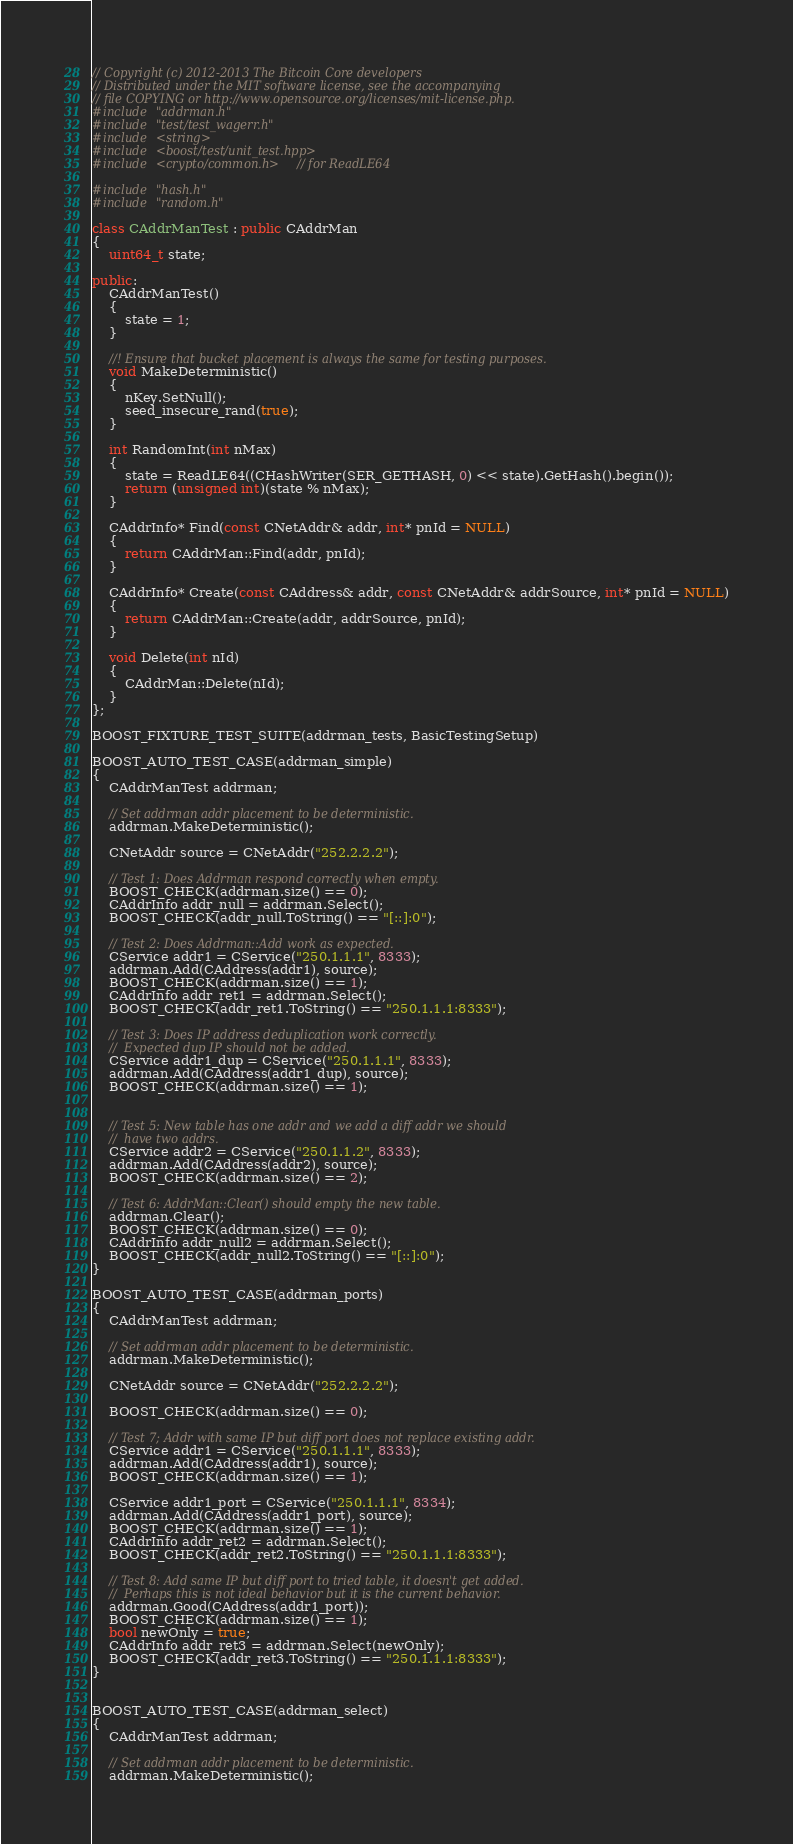<code> <loc_0><loc_0><loc_500><loc_500><_C++_>// Copyright (c) 2012-2013 The Bitcoin Core developers
// Distributed under the MIT software license, see the accompanying
// file COPYING or http://www.opensource.org/licenses/mit-license.php.
#include "addrman.h"
#include "test/test_wagerr.h"
#include <string>
#include <boost/test/unit_test.hpp>
#include <crypto/common.h> // for ReadLE64

#include "hash.h"
#include "random.h"

class CAddrManTest : public CAddrMan
{
    uint64_t state;

public:
    CAddrManTest()
    {
        state = 1;
    }

    //! Ensure that bucket placement is always the same for testing purposes.
    void MakeDeterministic()
    {
        nKey.SetNull();
        seed_insecure_rand(true);
    }

    int RandomInt(int nMax)
    {
        state = ReadLE64((CHashWriter(SER_GETHASH, 0) << state).GetHash().begin());
        return (unsigned int)(state % nMax);
    }

    CAddrInfo* Find(const CNetAddr& addr, int* pnId = NULL)
    {
        return CAddrMan::Find(addr, pnId);
    }

    CAddrInfo* Create(const CAddress& addr, const CNetAddr& addrSource, int* pnId = NULL)
    {
        return CAddrMan::Create(addr, addrSource, pnId);
    }

    void Delete(int nId)
    {
        CAddrMan::Delete(nId);
    }
};

BOOST_FIXTURE_TEST_SUITE(addrman_tests, BasicTestingSetup)

BOOST_AUTO_TEST_CASE(addrman_simple)
{
    CAddrManTest addrman;

    // Set addrman addr placement to be deterministic.
    addrman.MakeDeterministic();

    CNetAddr source = CNetAddr("252.2.2.2");

    // Test 1: Does Addrman respond correctly when empty.
    BOOST_CHECK(addrman.size() == 0);
    CAddrInfo addr_null = addrman.Select();
    BOOST_CHECK(addr_null.ToString() == "[::]:0");

    // Test 2: Does Addrman::Add work as expected.
    CService addr1 = CService("250.1.1.1", 8333);
    addrman.Add(CAddress(addr1), source);
    BOOST_CHECK(addrman.size() == 1);
    CAddrInfo addr_ret1 = addrman.Select();
    BOOST_CHECK(addr_ret1.ToString() == "250.1.1.1:8333");

    // Test 3: Does IP address deduplication work correctly.
    //  Expected dup IP should not be added.
    CService addr1_dup = CService("250.1.1.1", 8333);
    addrman.Add(CAddress(addr1_dup), source);
    BOOST_CHECK(addrman.size() == 1);


    // Test 5: New table has one addr and we add a diff addr we should
    //  have two addrs.
    CService addr2 = CService("250.1.1.2", 8333);
    addrman.Add(CAddress(addr2), source);
    BOOST_CHECK(addrman.size() == 2);

    // Test 6: AddrMan::Clear() should empty the new table.
    addrman.Clear();
    BOOST_CHECK(addrman.size() == 0);
    CAddrInfo addr_null2 = addrman.Select();
    BOOST_CHECK(addr_null2.ToString() == "[::]:0");
}

BOOST_AUTO_TEST_CASE(addrman_ports)
{
    CAddrManTest addrman;

    // Set addrman addr placement to be deterministic.
    addrman.MakeDeterministic();

    CNetAddr source = CNetAddr("252.2.2.2");

    BOOST_CHECK(addrman.size() == 0);

    // Test 7; Addr with same IP but diff port does not replace existing addr.
    CService addr1 = CService("250.1.1.1", 8333);
    addrman.Add(CAddress(addr1), source);
    BOOST_CHECK(addrman.size() == 1);

    CService addr1_port = CService("250.1.1.1", 8334);
    addrman.Add(CAddress(addr1_port), source);
    BOOST_CHECK(addrman.size() == 1);
    CAddrInfo addr_ret2 = addrman.Select();
    BOOST_CHECK(addr_ret2.ToString() == "250.1.1.1:8333");

    // Test 8: Add same IP but diff port to tried table, it doesn't get added.
    //  Perhaps this is not ideal behavior but it is the current behavior.
    addrman.Good(CAddress(addr1_port));
    BOOST_CHECK(addrman.size() == 1);
    bool newOnly = true;
    CAddrInfo addr_ret3 = addrman.Select(newOnly);
    BOOST_CHECK(addr_ret3.ToString() == "250.1.1.1:8333");
}


BOOST_AUTO_TEST_CASE(addrman_select)
{
    CAddrManTest addrman;

    // Set addrman addr placement to be deterministic.
    addrman.MakeDeterministic();
</code> 